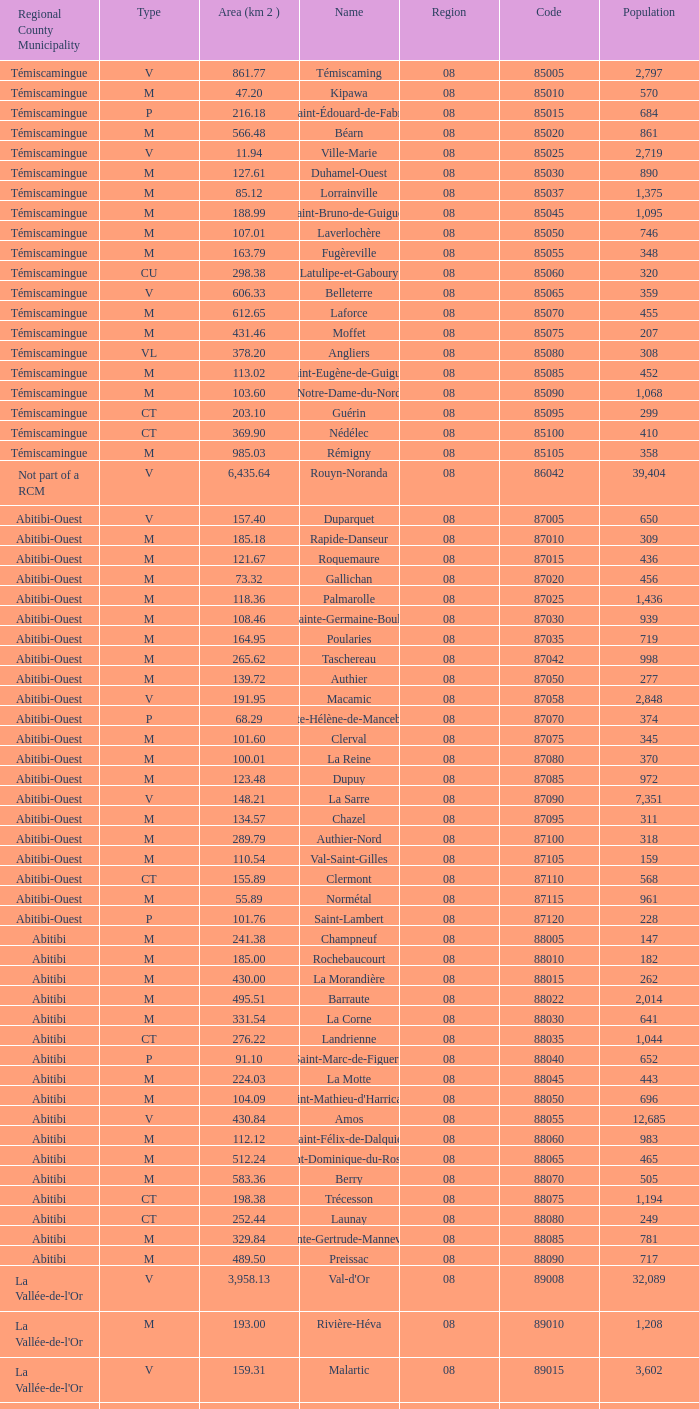What was the region for Malartic with 159.31 km2? 0.0. 